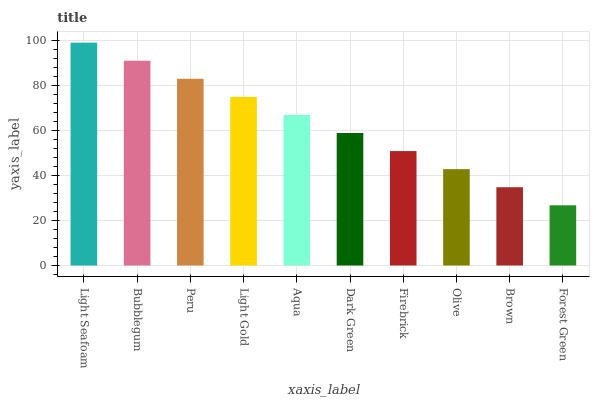Is Forest Green the minimum?
Answer yes or no. Yes. Is Light Seafoam the maximum?
Answer yes or no. Yes. Is Bubblegum the minimum?
Answer yes or no. No. Is Bubblegum the maximum?
Answer yes or no. No. Is Light Seafoam greater than Bubblegum?
Answer yes or no. Yes. Is Bubblegum less than Light Seafoam?
Answer yes or no. Yes. Is Bubblegum greater than Light Seafoam?
Answer yes or no. No. Is Light Seafoam less than Bubblegum?
Answer yes or no. No. Is Aqua the high median?
Answer yes or no. Yes. Is Dark Green the low median?
Answer yes or no. Yes. Is Forest Green the high median?
Answer yes or no. No. Is Light Gold the low median?
Answer yes or no. No. 